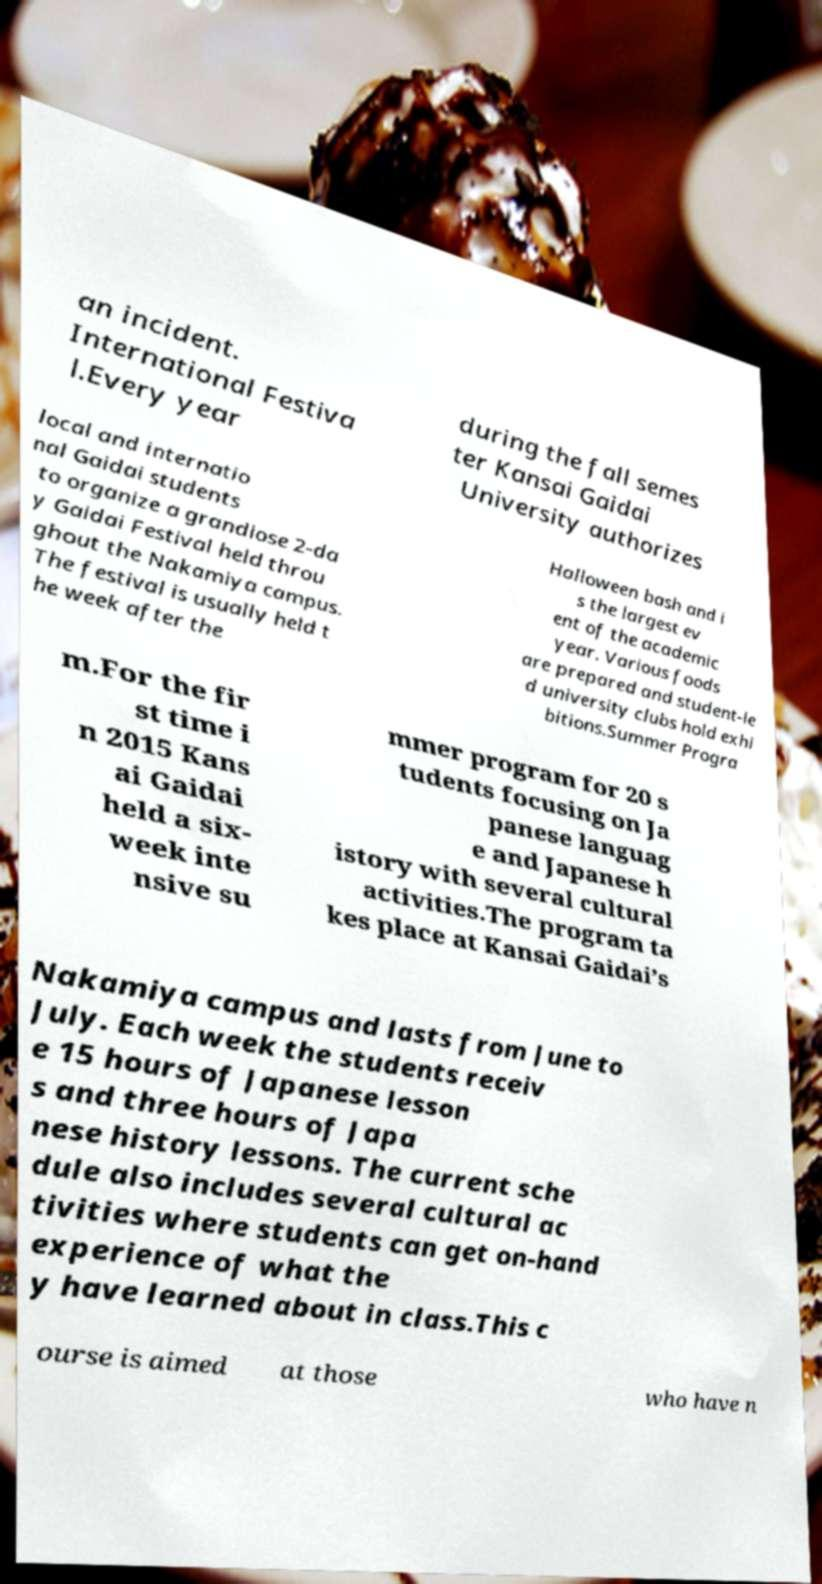There's text embedded in this image that I need extracted. Can you transcribe it verbatim? an incident. International Festiva l.Every year during the fall semes ter Kansai Gaidai University authorizes local and internatio nal Gaidai students to organize a grandiose 2-da y Gaidai Festival held throu ghout the Nakamiya campus. The festival is usually held t he week after the Halloween bash and i s the largest ev ent of the academic year. Various foods are prepared and student-le d university clubs hold exhi bitions.Summer Progra m.For the fir st time i n 2015 Kans ai Gaidai held a six- week inte nsive su mmer program for 20 s tudents focusing on Ja panese languag e and Japanese h istory with several cultural activities.The program ta kes place at Kansai Gaidai’s Nakamiya campus and lasts from June to July. Each week the students receiv e 15 hours of Japanese lesson s and three hours of Japa nese history lessons. The current sche dule also includes several cultural ac tivities where students can get on-hand experience of what the y have learned about in class.This c ourse is aimed at those who have n 